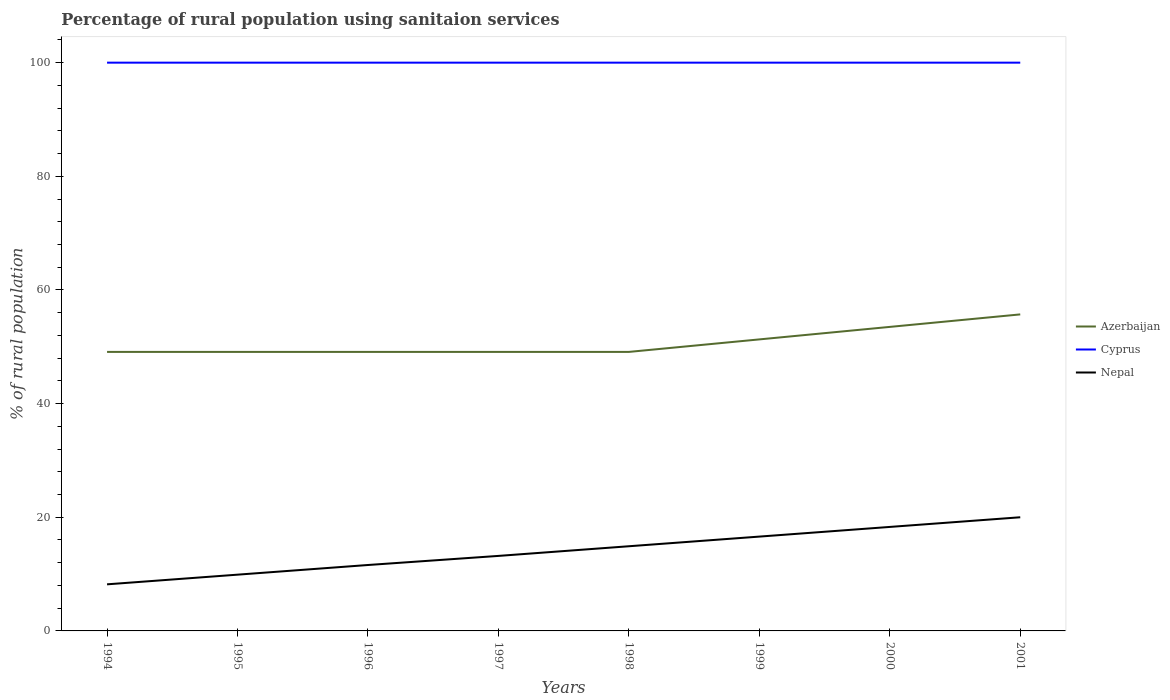Is the number of lines equal to the number of legend labels?
Give a very brief answer. Yes. Across all years, what is the maximum percentage of rural population using sanitaion services in Azerbaijan?
Ensure brevity in your answer.  49.1. In which year was the percentage of rural population using sanitaion services in Cyprus maximum?
Provide a succinct answer. 1994. What is the total percentage of rural population using sanitaion services in Cyprus in the graph?
Give a very brief answer. 0. What is the difference between the highest and the lowest percentage of rural population using sanitaion services in Nepal?
Your answer should be very brief. 4. Is the percentage of rural population using sanitaion services in Azerbaijan strictly greater than the percentage of rural population using sanitaion services in Cyprus over the years?
Offer a terse response. Yes. Are the values on the major ticks of Y-axis written in scientific E-notation?
Make the answer very short. No. Does the graph contain any zero values?
Provide a succinct answer. No. Where does the legend appear in the graph?
Ensure brevity in your answer.  Center right. How many legend labels are there?
Provide a short and direct response. 3. What is the title of the graph?
Offer a terse response. Percentage of rural population using sanitaion services. Does "Gambia, The" appear as one of the legend labels in the graph?
Offer a terse response. No. What is the label or title of the X-axis?
Make the answer very short. Years. What is the label or title of the Y-axis?
Provide a short and direct response. % of rural population. What is the % of rural population in Azerbaijan in 1994?
Your answer should be compact. 49.1. What is the % of rural population of Azerbaijan in 1995?
Offer a very short reply. 49.1. What is the % of rural population in Nepal in 1995?
Provide a short and direct response. 9.9. What is the % of rural population in Azerbaijan in 1996?
Offer a very short reply. 49.1. What is the % of rural population in Cyprus in 1996?
Offer a terse response. 100. What is the % of rural population in Azerbaijan in 1997?
Your response must be concise. 49.1. What is the % of rural population of Azerbaijan in 1998?
Provide a succinct answer. 49.1. What is the % of rural population of Cyprus in 1998?
Offer a very short reply. 100. What is the % of rural population in Azerbaijan in 1999?
Give a very brief answer. 51.3. What is the % of rural population in Cyprus in 1999?
Provide a succinct answer. 100. What is the % of rural population in Nepal in 1999?
Offer a terse response. 16.6. What is the % of rural population of Azerbaijan in 2000?
Ensure brevity in your answer.  53.5. What is the % of rural population in Cyprus in 2000?
Make the answer very short. 100. What is the % of rural population in Nepal in 2000?
Give a very brief answer. 18.3. What is the % of rural population of Azerbaijan in 2001?
Provide a succinct answer. 55.7. Across all years, what is the maximum % of rural population in Azerbaijan?
Make the answer very short. 55.7. Across all years, what is the maximum % of rural population in Cyprus?
Provide a short and direct response. 100. Across all years, what is the maximum % of rural population of Nepal?
Offer a terse response. 20. Across all years, what is the minimum % of rural population in Azerbaijan?
Ensure brevity in your answer.  49.1. What is the total % of rural population in Azerbaijan in the graph?
Offer a very short reply. 406. What is the total % of rural population of Cyprus in the graph?
Provide a short and direct response. 800. What is the total % of rural population of Nepal in the graph?
Provide a succinct answer. 112.7. What is the difference between the % of rural population in Nepal in 1994 and that in 1995?
Your answer should be very brief. -1.7. What is the difference between the % of rural population in Azerbaijan in 1994 and that in 1996?
Your answer should be very brief. 0. What is the difference between the % of rural population in Cyprus in 1994 and that in 1996?
Ensure brevity in your answer.  0. What is the difference between the % of rural population in Nepal in 1994 and that in 1996?
Offer a very short reply. -3.4. What is the difference between the % of rural population in Azerbaijan in 1994 and that in 1998?
Ensure brevity in your answer.  0. What is the difference between the % of rural population in Cyprus in 1994 and that in 1999?
Provide a short and direct response. 0. What is the difference between the % of rural population in Nepal in 1994 and that in 1999?
Give a very brief answer. -8.4. What is the difference between the % of rural population in Azerbaijan in 1994 and that in 2001?
Offer a very short reply. -6.6. What is the difference between the % of rural population of Nepal in 1994 and that in 2001?
Your answer should be compact. -11.8. What is the difference between the % of rural population of Azerbaijan in 1995 and that in 1996?
Keep it short and to the point. 0. What is the difference between the % of rural population of Cyprus in 1995 and that in 1996?
Your answer should be compact. 0. What is the difference between the % of rural population of Nepal in 1995 and that in 1996?
Your answer should be very brief. -1.7. What is the difference between the % of rural population of Nepal in 1995 and that in 1997?
Provide a succinct answer. -3.3. What is the difference between the % of rural population in Azerbaijan in 1995 and that in 1998?
Keep it short and to the point. 0. What is the difference between the % of rural population in Cyprus in 1995 and that in 1998?
Offer a terse response. 0. What is the difference between the % of rural population of Azerbaijan in 1995 and that in 1999?
Offer a terse response. -2.2. What is the difference between the % of rural population of Nepal in 1995 and that in 1999?
Offer a terse response. -6.7. What is the difference between the % of rural population of Azerbaijan in 1995 and that in 2001?
Provide a short and direct response. -6.6. What is the difference between the % of rural population of Nepal in 1995 and that in 2001?
Keep it short and to the point. -10.1. What is the difference between the % of rural population of Cyprus in 1996 and that in 1998?
Your answer should be very brief. 0. What is the difference between the % of rural population in Azerbaijan in 1996 and that in 1999?
Offer a terse response. -2.2. What is the difference between the % of rural population of Cyprus in 1996 and that in 1999?
Provide a succinct answer. 0. What is the difference between the % of rural population in Nepal in 1996 and that in 1999?
Ensure brevity in your answer.  -5. What is the difference between the % of rural population in Cyprus in 1996 and that in 2001?
Your answer should be compact. 0. What is the difference between the % of rural population of Nepal in 1996 and that in 2001?
Give a very brief answer. -8.4. What is the difference between the % of rural population in Cyprus in 1997 and that in 1998?
Your response must be concise. 0. What is the difference between the % of rural population of Nepal in 1997 and that in 1998?
Keep it short and to the point. -1.7. What is the difference between the % of rural population of Cyprus in 1997 and that in 1999?
Keep it short and to the point. 0. What is the difference between the % of rural population of Nepal in 1997 and that in 1999?
Provide a short and direct response. -3.4. What is the difference between the % of rural population of Azerbaijan in 1997 and that in 2000?
Your response must be concise. -4.4. What is the difference between the % of rural population of Nepal in 1997 and that in 2000?
Offer a terse response. -5.1. What is the difference between the % of rural population of Azerbaijan in 1998 and that in 1999?
Keep it short and to the point. -2.2. What is the difference between the % of rural population in Nepal in 1998 and that in 1999?
Your response must be concise. -1.7. What is the difference between the % of rural population in Nepal in 1998 and that in 2000?
Provide a short and direct response. -3.4. What is the difference between the % of rural population in Azerbaijan in 1999 and that in 2000?
Make the answer very short. -2.2. What is the difference between the % of rural population in Azerbaijan in 1999 and that in 2001?
Offer a very short reply. -4.4. What is the difference between the % of rural population in Cyprus in 1999 and that in 2001?
Keep it short and to the point. 0. What is the difference between the % of rural population of Nepal in 2000 and that in 2001?
Your answer should be compact. -1.7. What is the difference between the % of rural population in Azerbaijan in 1994 and the % of rural population in Cyprus in 1995?
Provide a short and direct response. -50.9. What is the difference between the % of rural population of Azerbaijan in 1994 and the % of rural population of Nepal in 1995?
Provide a short and direct response. 39.2. What is the difference between the % of rural population of Cyprus in 1994 and the % of rural population of Nepal in 1995?
Your answer should be compact. 90.1. What is the difference between the % of rural population of Azerbaijan in 1994 and the % of rural population of Cyprus in 1996?
Offer a very short reply. -50.9. What is the difference between the % of rural population of Azerbaijan in 1994 and the % of rural population of Nepal in 1996?
Ensure brevity in your answer.  37.5. What is the difference between the % of rural population of Cyprus in 1994 and the % of rural population of Nepal in 1996?
Offer a terse response. 88.4. What is the difference between the % of rural population of Azerbaijan in 1994 and the % of rural population of Cyprus in 1997?
Offer a terse response. -50.9. What is the difference between the % of rural population of Azerbaijan in 1994 and the % of rural population of Nepal in 1997?
Provide a succinct answer. 35.9. What is the difference between the % of rural population of Cyprus in 1994 and the % of rural population of Nepal in 1997?
Provide a succinct answer. 86.8. What is the difference between the % of rural population of Azerbaijan in 1994 and the % of rural population of Cyprus in 1998?
Provide a short and direct response. -50.9. What is the difference between the % of rural population in Azerbaijan in 1994 and the % of rural population in Nepal in 1998?
Give a very brief answer. 34.2. What is the difference between the % of rural population of Cyprus in 1994 and the % of rural population of Nepal in 1998?
Provide a short and direct response. 85.1. What is the difference between the % of rural population in Azerbaijan in 1994 and the % of rural population in Cyprus in 1999?
Provide a succinct answer. -50.9. What is the difference between the % of rural population of Azerbaijan in 1994 and the % of rural population of Nepal in 1999?
Your answer should be compact. 32.5. What is the difference between the % of rural population of Cyprus in 1994 and the % of rural population of Nepal in 1999?
Keep it short and to the point. 83.4. What is the difference between the % of rural population of Azerbaijan in 1994 and the % of rural population of Cyprus in 2000?
Your answer should be compact. -50.9. What is the difference between the % of rural population in Azerbaijan in 1994 and the % of rural population in Nepal in 2000?
Keep it short and to the point. 30.8. What is the difference between the % of rural population in Cyprus in 1994 and the % of rural population in Nepal in 2000?
Ensure brevity in your answer.  81.7. What is the difference between the % of rural population in Azerbaijan in 1994 and the % of rural population in Cyprus in 2001?
Provide a succinct answer. -50.9. What is the difference between the % of rural population of Azerbaijan in 1994 and the % of rural population of Nepal in 2001?
Make the answer very short. 29.1. What is the difference between the % of rural population in Azerbaijan in 1995 and the % of rural population in Cyprus in 1996?
Provide a succinct answer. -50.9. What is the difference between the % of rural population of Azerbaijan in 1995 and the % of rural population of Nepal in 1996?
Your answer should be very brief. 37.5. What is the difference between the % of rural population in Cyprus in 1995 and the % of rural population in Nepal in 1996?
Keep it short and to the point. 88.4. What is the difference between the % of rural population of Azerbaijan in 1995 and the % of rural population of Cyprus in 1997?
Provide a succinct answer. -50.9. What is the difference between the % of rural population in Azerbaijan in 1995 and the % of rural population in Nepal in 1997?
Keep it short and to the point. 35.9. What is the difference between the % of rural population in Cyprus in 1995 and the % of rural population in Nepal in 1997?
Give a very brief answer. 86.8. What is the difference between the % of rural population in Azerbaijan in 1995 and the % of rural population in Cyprus in 1998?
Provide a succinct answer. -50.9. What is the difference between the % of rural population of Azerbaijan in 1995 and the % of rural population of Nepal in 1998?
Ensure brevity in your answer.  34.2. What is the difference between the % of rural population of Cyprus in 1995 and the % of rural population of Nepal in 1998?
Provide a short and direct response. 85.1. What is the difference between the % of rural population in Azerbaijan in 1995 and the % of rural population in Cyprus in 1999?
Provide a short and direct response. -50.9. What is the difference between the % of rural population of Azerbaijan in 1995 and the % of rural population of Nepal in 1999?
Provide a short and direct response. 32.5. What is the difference between the % of rural population of Cyprus in 1995 and the % of rural population of Nepal in 1999?
Offer a terse response. 83.4. What is the difference between the % of rural population in Azerbaijan in 1995 and the % of rural population in Cyprus in 2000?
Offer a terse response. -50.9. What is the difference between the % of rural population of Azerbaijan in 1995 and the % of rural population of Nepal in 2000?
Offer a very short reply. 30.8. What is the difference between the % of rural population in Cyprus in 1995 and the % of rural population in Nepal in 2000?
Your answer should be compact. 81.7. What is the difference between the % of rural population of Azerbaijan in 1995 and the % of rural population of Cyprus in 2001?
Provide a short and direct response. -50.9. What is the difference between the % of rural population of Azerbaijan in 1995 and the % of rural population of Nepal in 2001?
Keep it short and to the point. 29.1. What is the difference between the % of rural population of Cyprus in 1995 and the % of rural population of Nepal in 2001?
Provide a short and direct response. 80. What is the difference between the % of rural population of Azerbaijan in 1996 and the % of rural population of Cyprus in 1997?
Offer a terse response. -50.9. What is the difference between the % of rural population of Azerbaijan in 1996 and the % of rural population of Nepal in 1997?
Ensure brevity in your answer.  35.9. What is the difference between the % of rural population of Cyprus in 1996 and the % of rural population of Nepal in 1997?
Offer a terse response. 86.8. What is the difference between the % of rural population of Azerbaijan in 1996 and the % of rural population of Cyprus in 1998?
Provide a short and direct response. -50.9. What is the difference between the % of rural population of Azerbaijan in 1996 and the % of rural population of Nepal in 1998?
Your answer should be compact. 34.2. What is the difference between the % of rural population of Cyprus in 1996 and the % of rural population of Nepal in 1998?
Keep it short and to the point. 85.1. What is the difference between the % of rural population of Azerbaijan in 1996 and the % of rural population of Cyprus in 1999?
Give a very brief answer. -50.9. What is the difference between the % of rural population in Azerbaijan in 1996 and the % of rural population in Nepal in 1999?
Provide a short and direct response. 32.5. What is the difference between the % of rural population in Cyprus in 1996 and the % of rural population in Nepal in 1999?
Keep it short and to the point. 83.4. What is the difference between the % of rural population in Azerbaijan in 1996 and the % of rural population in Cyprus in 2000?
Keep it short and to the point. -50.9. What is the difference between the % of rural population of Azerbaijan in 1996 and the % of rural population of Nepal in 2000?
Keep it short and to the point. 30.8. What is the difference between the % of rural population in Cyprus in 1996 and the % of rural population in Nepal in 2000?
Make the answer very short. 81.7. What is the difference between the % of rural population of Azerbaijan in 1996 and the % of rural population of Cyprus in 2001?
Make the answer very short. -50.9. What is the difference between the % of rural population in Azerbaijan in 1996 and the % of rural population in Nepal in 2001?
Keep it short and to the point. 29.1. What is the difference between the % of rural population in Cyprus in 1996 and the % of rural population in Nepal in 2001?
Keep it short and to the point. 80. What is the difference between the % of rural population in Azerbaijan in 1997 and the % of rural population in Cyprus in 1998?
Make the answer very short. -50.9. What is the difference between the % of rural population of Azerbaijan in 1997 and the % of rural population of Nepal in 1998?
Ensure brevity in your answer.  34.2. What is the difference between the % of rural population of Cyprus in 1997 and the % of rural population of Nepal in 1998?
Provide a succinct answer. 85.1. What is the difference between the % of rural population of Azerbaijan in 1997 and the % of rural population of Cyprus in 1999?
Offer a very short reply. -50.9. What is the difference between the % of rural population of Azerbaijan in 1997 and the % of rural population of Nepal in 1999?
Keep it short and to the point. 32.5. What is the difference between the % of rural population of Cyprus in 1997 and the % of rural population of Nepal in 1999?
Your answer should be compact. 83.4. What is the difference between the % of rural population of Azerbaijan in 1997 and the % of rural population of Cyprus in 2000?
Your answer should be very brief. -50.9. What is the difference between the % of rural population of Azerbaijan in 1997 and the % of rural population of Nepal in 2000?
Your answer should be compact. 30.8. What is the difference between the % of rural population of Cyprus in 1997 and the % of rural population of Nepal in 2000?
Your response must be concise. 81.7. What is the difference between the % of rural population in Azerbaijan in 1997 and the % of rural population in Cyprus in 2001?
Provide a short and direct response. -50.9. What is the difference between the % of rural population of Azerbaijan in 1997 and the % of rural population of Nepal in 2001?
Provide a short and direct response. 29.1. What is the difference between the % of rural population in Azerbaijan in 1998 and the % of rural population in Cyprus in 1999?
Your response must be concise. -50.9. What is the difference between the % of rural population of Azerbaijan in 1998 and the % of rural population of Nepal in 1999?
Your answer should be very brief. 32.5. What is the difference between the % of rural population of Cyprus in 1998 and the % of rural population of Nepal in 1999?
Your response must be concise. 83.4. What is the difference between the % of rural population in Azerbaijan in 1998 and the % of rural population in Cyprus in 2000?
Your answer should be compact. -50.9. What is the difference between the % of rural population in Azerbaijan in 1998 and the % of rural population in Nepal in 2000?
Your response must be concise. 30.8. What is the difference between the % of rural population in Cyprus in 1998 and the % of rural population in Nepal in 2000?
Keep it short and to the point. 81.7. What is the difference between the % of rural population of Azerbaijan in 1998 and the % of rural population of Cyprus in 2001?
Provide a short and direct response. -50.9. What is the difference between the % of rural population in Azerbaijan in 1998 and the % of rural population in Nepal in 2001?
Keep it short and to the point. 29.1. What is the difference between the % of rural population in Azerbaijan in 1999 and the % of rural population in Cyprus in 2000?
Offer a terse response. -48.7. What is the difference between the % of rural population in Cyprus in 1999 and the % of rural population in Nepal in 2000?
Provide a succinct answer. 81.7. What is the difference between the % of rural population of Azerbaijan in 1999 and the % of rural population of Cyprus in 2001?
Your answer should be very brief. -48.7. What is the difference between the % of rural population of Azerbaijan in 1999 and the % of rural population of Nepal in 2001?
Your answer should be compact. 31.3. What is the difference between the % of rural population of Cyprus in 1999 and the % of rural population of Nepal in 2001?
Your answer should be compact. 80. What is the difference between the % of rural population of Azerbaijan in 2000 and the % of rural population of Cyprus in 2001?
Offer a very short reply. -46.5. What is the difference between the % of rural population of Azerbaijan in 2000 and the % of rural population of Nepal in 2001?
Your answer should be very brief. 33.5. What is the difference between the % of rural population in Cyprus in 2000 and the % of rural population in Nepal in 2001?
Your response must be concise. 80. What is the average % of rural population in Azerbaijan per year?
Provide a succinct answer. 50.75. What is the average % of rural population of Nepal per year?
Your answer should be very brief. 14.09. In the year 1994, what is the difference between the % of rural population of Azerbaijan and % of rural population of Cyprus?
Provide a succinct answer. -50.9. In the year 1994, what is the difference between the % of rural population in Azerbaijan and % of rural population in Nepal?
Your response must be concise. 40.9. In the year 1994, what is the difference between the % of rural population in Cyprus and % of rural population in Nepal?
Your answer should be very brief. 91.8. In the year 1995, what is the difference between the % of rural population of Azerbaijan and % of rural population of Cyprus?
Make the answer very short. -50.9. In the year 1995, what is the difference between the % of rural population of Azerbaijan and % of rural population of Nepal?
Give a very brief answer. 39.2. In the year 1995, what is the difference between the % of rural population in Cyprus and % of rural population in Nepal?
Keep it short and to the point. 90.1. In the year 1996, what is the difference between the % of rural population of Azerbaijan and % of rural population of Cyprus?
Offer a terse response. -50.9. In the year 1996, what is the difference between the % of rural population of Azerbaijan and % of rural population of Nepal?
Your response must be concise. 37.5. In the year 1996, what is the difference between the % of rural population of Cyprus and % of rural population of Nepal?
Ensure brevity in your answer.  88.4. In the year 1997, what is the difference between the % of rural population in Azerbaijan and % of rural population in Cyprus?
Provide a short and direct response. -50.9. In the year 1997, what is the difference between the % of rural population of Azerbaijan and % of rural population of Nepal?
Offer a very short reply. 35.9. In the year 1997, what is the difference between the % of rural population in Cyprus and % of rural population in Nepal?
Your response must be concise. 86.8. In the year 1998, what is the difference between the % of rural population of Azerbaijan and % of rural population of Cyprus?
Offer a very short reply. -50.9. In the year 1998, what is the difference between the % of rural population in Azerbaijan and % of rural population in Nepal?
Offer a very short reply. 34.2. In the year 1998, what is the difference between the % of rural population of Cyprus and % of rural population of Nepal?
Your answer should be very brief. 85.1. In the year 1999, what is the difference between the % of rural population of Azerbaijan and % of rural population of Cyprus?
Provide a succinct answer. -48.7. In the year 1999, what is the difference between the % of rural population in Azerbaijan and % of rural population in Nepal?
Your answer should be compact. 34.7. In the year 1999, what is the difference between the % of rural population of Cyprus and % of rural population of Nepal?
Your answer should be compact. 83.4. In the year 2000, what is the difference between the % of rural population of Azerbaijan and % of rural population of Cyprus?
Your answer should be very brief. -46.5. In the year 2000, what is the difference between the % of rural population in Azerbaijan and % of rural population in Nepal?
Offer a very short reply. 35.2. In the year 2000, what is the difference between the % of rural population of Cyprus and % of rural population of Nepal?
Make the answer very short. 81.7. In the year 2001, what is the difference between the % of rural population of Azerbaijan and % of rural population of Cyprus?
Make the answer very short. -44.3. In the year 2001, what is the difference between the % of rural population of Azerbaijan and % of rural population of Nepal?
Ensure brevity in your answer.  35.7. What is the ratio of the % of rural population in Azerbaijan in 1994 to that in 1995?
Provide a short and direct response. 1. What is the ratio of the % of rural population of Cyprus in 1994 to that in 1995?
Provide a succinct answer. 1. What is the ratio of the % of rural population in Nepal in 1994 to that in 1995?
Keep it short and to the point. 0.83. What is the ratio of the % of rural population of Cyprus in 1994 to that in 1996?
Provide a succinct answer. 1. What is the ratio of the % of rural population in Nepal in 1994 to that in 1996?
Give a very brief answer. 0.71. What is the ratio of the % of rural population of Cyprus in 1994 to that in 1997?
Offer a very short reply. 1. What is the ratio of the % of rural population of Nepal in 1994 to that in 1997?
Offer a very short reply. 0.62. What is the ratio of the % of rural population of Nepal in 1994 to that in 1998?
Give a very brief answer. 0.55. What is the ratio of the % of rural population of Azerbaijan in 1994 to that in 1999?
Ensure brevity in your answer.  0.96. What is the ratio of the % of rural population in Cyprus in 1994 to that in 1999?
Offer a very short reply. 1. What is the ratio of the % of rural population of Nepal in 1994 to that in 1999?
Your answer should be very brief. 0.49. What is the ratio of the % of rural population of Azerbaijan in 1994 to that in 2000?
Your response must be concise. 0.92. What is the ratio of the % of rural population of Nepal in 1994 to that in 2000?
Give a very brief answer. 0.45. What is the ratio of the % of rural population of Azerbaijan in 1994 to that in 2001?
Make the answer very short. 0.88. What is the ratio of the % of rural population of Cyprus in 1994 to that in 2001?
Provide a succinct answer. 1. What is the ratio of the % of rural population in Nepal in 1994 to that in 2001?
Give a very brief answer. 0.41. What is the ratio of the % of rural population of Azerbaijan in 1995 to that in 1996?
Your answer should be very brief. 1. What is the ratio of the % of rural population of Cyprus in 1995 to that in 1996?
Provide a succinct answer. 1. What is the ratio of the % of rural population in Nepal in 1995 to that in 1996?
Make the answer very short. 0.85. What is the ratio of the % of rural population in Cyprus in 1995 to that in 1997?
Keep it short and to the point. 1. What is the ratio of the % of rural population of Nepal in 1995 to that in 1997?
Offer a terse response. 0.75. What is the ratio of the % of rural population in Nepal in 1995 to that in 1998?
Offer a terse response. 0.66. What is the ratio of the % of rural population in Azerbaijan in 1995 to that in 1999?
Provide a succinct answer. 0.96. What is the ratio of the % of rural population in Nepal in 1995 to that in 1999?
Offer a terse response. 0.6. What is the ratio of the % of rural population in Azerbaijan in 1995 to that in 2000?
Your answer should be compact. 0.92. What is the ratio of the % of rural population of Cyprus in 1995 to that in 2000?
Your answer should be compact. 1. What is the ratio of the % of rural population of Nepal in 1995 to that in 2000?
Your answer should be compact. 0.54. What is the ratio of the % of rural population in Azerbaijan in 1995 to that in 2001?
Offer a terse response. 0.88. What is the ratio of the % of rural population in Nepal in 1995 to that in 2001?
Offer a terse response. 0.49. What is the ratio of the % of rural population of Cyprus in 1996 to that in 1997?
Keep it short and to the point. 1. What is the ratio of the % of rural population of Nepal in 1996 to that in 1997?
Provide a succinct answer. 0.88. What is the ratio of the % of rural population in Cyprus in 1996 to that in 1998?
Provide a succinct answer. 1. What is the ratio of the % of rural population of Nepal in 1996 to that in 1998?
Your answer should be compact. 0.78. What is the ratio of the % of rural population of Azerbaijan in 1996 to that in 1999?
Give a very brief answer. 0.96. What is the ratio of the % of rural population of Cyprus in 1996 to that in 1999?
Offer a terse response. 1. What is the ratio of the % of rural population of Nepal in 1996 to that in 1999?
Offer a very short reply. 0.7. What is the ratio of the % of rural population of Azerbaijan in 1996 to that in 2000?
Make the answer very short. 0.92. What is the ratio of the % of rural population of Cyprus in 1996 to that in 2000?
Provide a succinct answer. 1. What is the ratio of the % of rural population of Nepal in 1996 to that in 2000?
Ensure brevity in your answer.  0.63. What is the ratio of the % of rural population of Azerbaijan in 1996 to that in 2001?
Keep it short and to the point. 0.88. What is the ratio of the % of rural population in Cyprus in 1996 to that in 2001?
Provide a short and direct response. 1. What is the ratio of the % of rural population of Nepal in 1996 to that in 2001?
Make the answer very short. 0.58. What is the ratio of the % of rural population of Azerbaijan in 1997 to that in 1998?
Give a very brief answer. 1. What is the ratio of the % of rural population in Nepal in 1997 to that in 1998?
Provide a short and direct response. 0.89. What is the ratio of the % of rural population of Azerbaijan in 1997 to that in 1999?
Give a very brief answer. 0.96. What is the ratio of the % of rural population in Cyprus in 1997 to that in 1999?
Provide a short and direct response. 1. What is the ratio of the % of rural population of Nepal in 1997 to that in 1999?
Give a very brief answer. 0.8. What is the ratio of the % of rural population in Azerbaijan in 1997 to that in 2000?
Your answer should be very brief. 0.92. What is the ratio of the % of rural population in Cyprus in 1997 to that in 2000?
Your answer should be very brief. 1. What is the ratio of the % of rural population of Nepal in 1997 to that in 2000?
Keep it short and to the point. 0.72. What is the ratio of the % of rural population of Azerbaijan in 1997 to that in 2001?
Give a very brief answer. 0.88. What is the ratio of the % of rural population in Nepal in 1997 to that in 2001?
Provide a short and direct response. 0.66. What is the ratio of the % of rural population of Azerbaijan in 1998 to that in 1999?
Make the answer very short. 0.96. What is the ratio of the % of rural population in Cyprus in 1998 to that in 1999?
Give a very brief answer. 1. What is the ratio of the % of rural population in Nepal in 1998 to that in 1999?
Give a very brief answer. 0.9. What is the ratio of the % of rural population in Azerbaijan in 1998 to that in 2000?
Keep it short and to the point. 0.92. What is the ratio of the % of rural population of Cyprus in 1998 to that in 2000?
Offer a terse response. 1. What is the ratio of the % of rural population of Nepal in 1998 to that in 2000?
Give a very brief answer. 0.81. What is the ratio of the % of rural population of Azerbaijan in 1998 to that in 2001?
Ensure brevity in your answer.  0.88. What is the ratio of the % of rural population of Nepal in 1998 to that in 2001?
Your response must be concise. 0.74. What is the ratio of the % of rural population in Azerbaijan in 1999 to that in 2000?
Provide a succinct answer. 0.96. What is the ratio of the % of rural population in Nepal in 1999 to that in 2000?
Give a very brief answer. 0.91. What is the ratio of the % of rural population of Azerbaijan in 1999 to that in 2001?
Offer a very short reply. 0.92. What is the ratio of the % of rural population in Cyprus in 1999 to that in 2001?
Your answer should be compact. 1. What is the ratio of the % of rural population of Nepal in 1999 to that in 2001?
Offer a very short reply. 0.83. What is the ratio of the % of rural population of Azerbaijan in 2000 to that in 2001?
Provide a succinct answer. 0.96. What is the ratio of the % of rural population in Cyprus in 2000 to that in 2001?
Keep it short and to the point. 1. What is the ratio of the % of rural population in Nepal in 2000 to that in 2001?
Provide a succinct answer. 0.92. What is the difference between the highest and the second highest % of rural population of Azerbaijan?
Keep it short and to the point. 2.2. What is the difference between the highest and the second highest % of rural population of Cyprus?
Offer a terse response. 0. What is the difference between the highest and the second highest % of rural population of Nepal?
Your response must be concise. 1.7. What is the difference between the highest and the lowest % of rural population in Azerbaijan?
Your answer should be very brief. 6.6. 